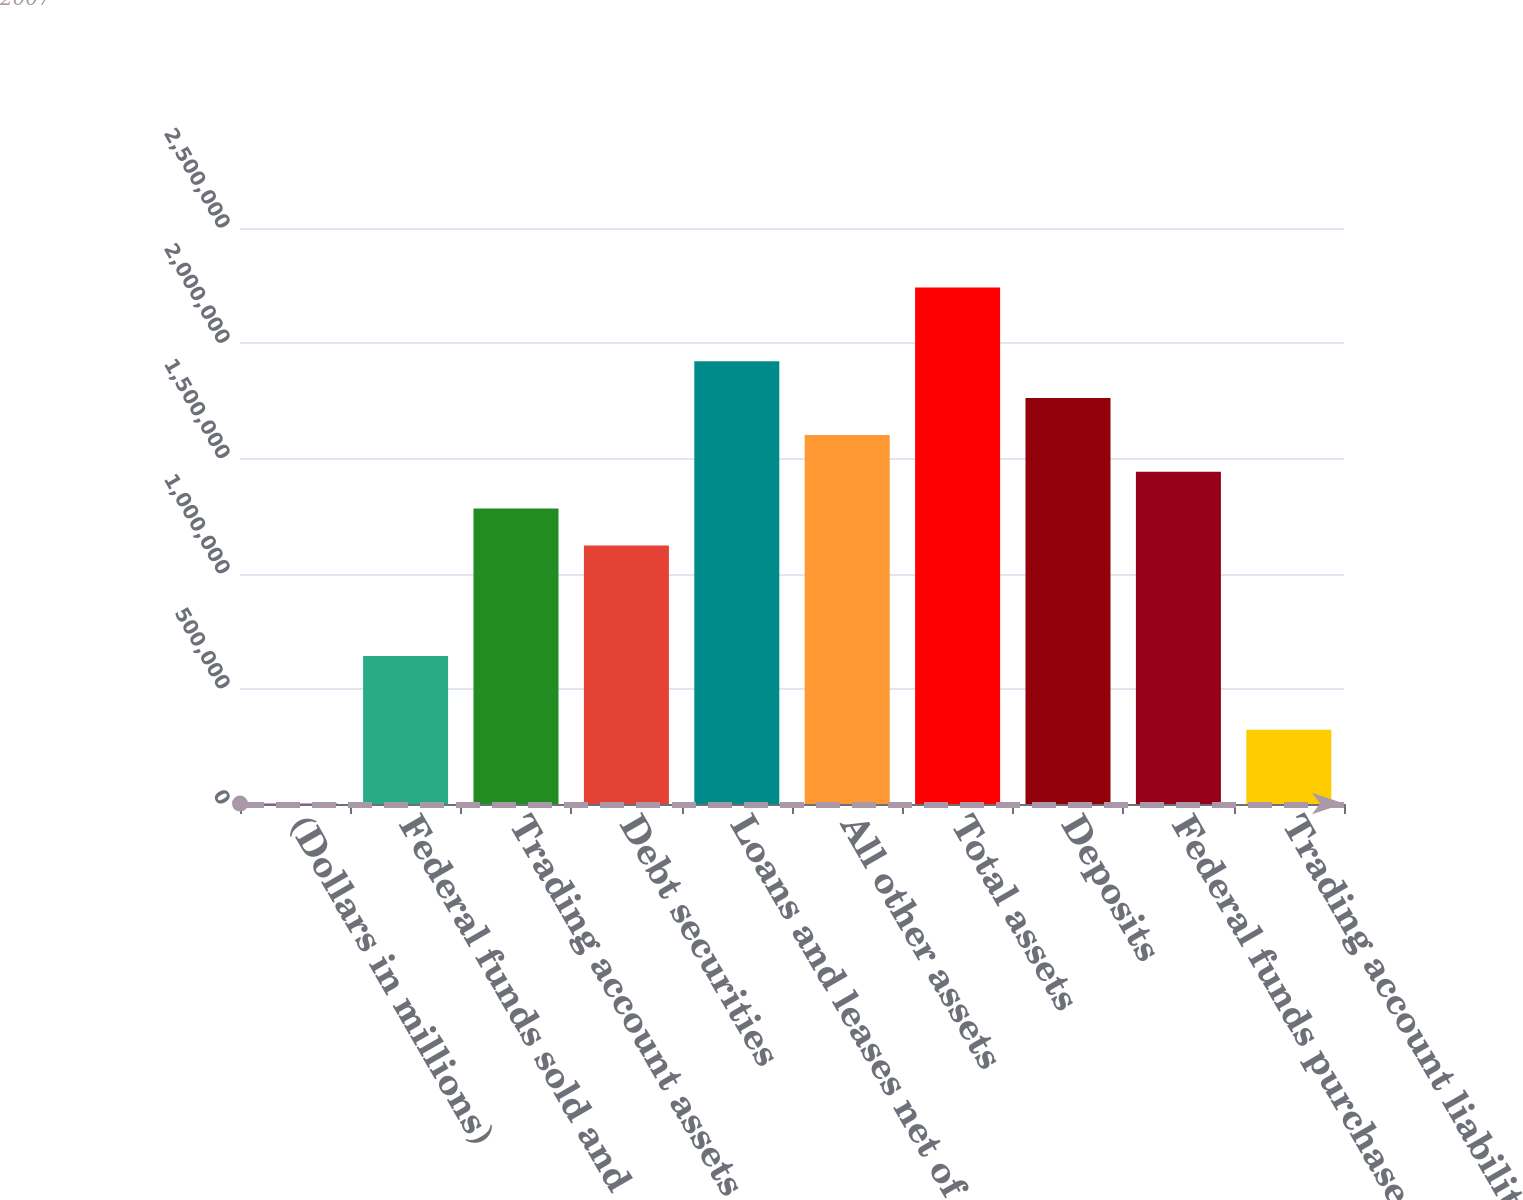Convert chart to OTSL. <chart><loc_0><loc_0><loc_500><loc_500><bar_chart><fcel>(Dollars in millions)<fcel>Federal funds sold and<fcel>Trading account assets<fcel>Debt securities<fcel>Loans and leases net of<fcel>All other assets<fcel>Total assets<fcel>Deposits<fcel>Federal funds purchased and<fcel>Trading account liabilities<nl><fcel>2007<fcel>642033<fcel>1.28206e+06<fcel>1.12205e+06<fcel>1.92209e+06<fcel>1.60207e+06<fcel>2.2421e+06<fcel>1.76208e+06<fcel>1.44207e+06<fcel>322020<nl></chart> 